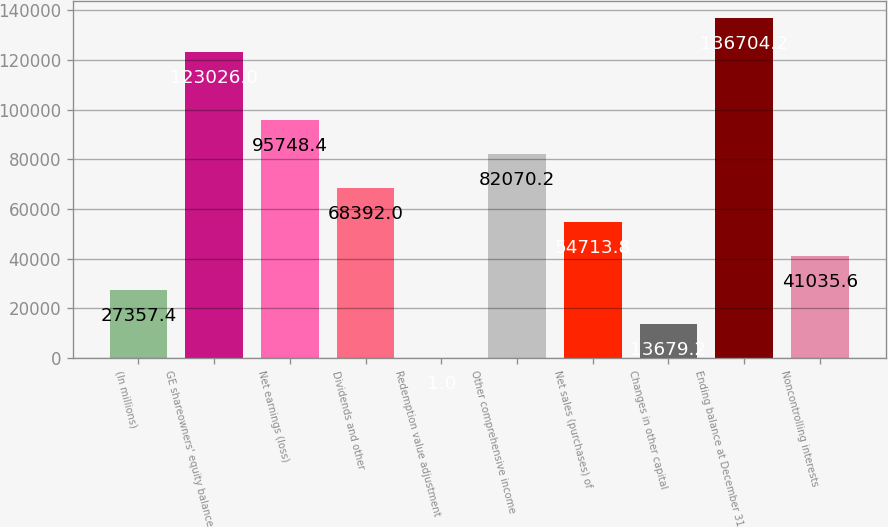Convert chart to OTSL. <chart><loc_0><loc_0><loc_500><loc_500><bar_chart><fcel>(In millions)<fcel>GE shareowners' equity balance<fcel>Net earnings (loss)<fcel>Dividends and other<fcel>Redemption value adjustment<fcel>Other comprehensive income<fcel>Net sales (purchases) of<fcel>Changes in other capital<fcel>Ending balance at December 31<fcel>Noncontrolling interests<nl><fcel>27357.4<fcel>123026<fcel>95748.4<fcel>68392<fcel>1<fcel>82070.2<fcel>54713.8<fcel>13679.2<fcel>136704<fcel>41035.6<nl></chart> 